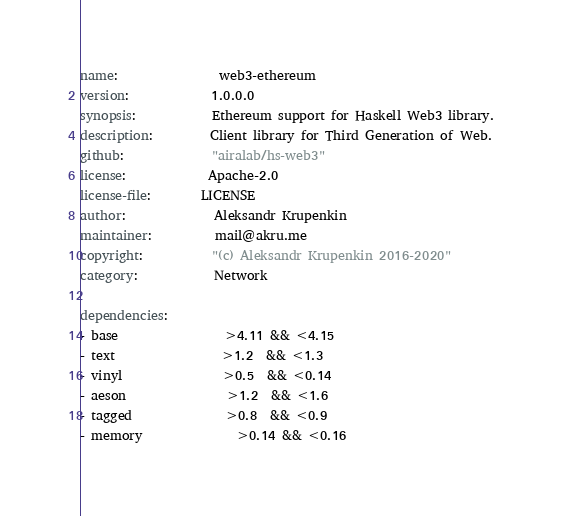Convert code to text. <code><loc_0><loc_0><loc_500><loc_500><_YAML_>name:                web3-ethereum
version:             1.0.0.0
synopsis:            Ethereum support for Haskell Web3 library.
description:         Client library for Third Generation of Web.
github:              "airalab/hs-web3"
license:             Apache-2.0
license-file:        LICENSE
author:              Aleksandr Krupenkin
maintainer:          mail@akru.me
copyright:           "(c) Aleksandr Krupenkin 2016-2020"
category:            Network

dependencies:
- base                 >4.11 && <4.15
- text                 >1.2  && <1.3
- vinyl                >0.5  && <0.14
- aeson                >1.2  && <1.6
- tagged               >0.8  && <0.9
- memory               >0.14 && <0.16</code> 